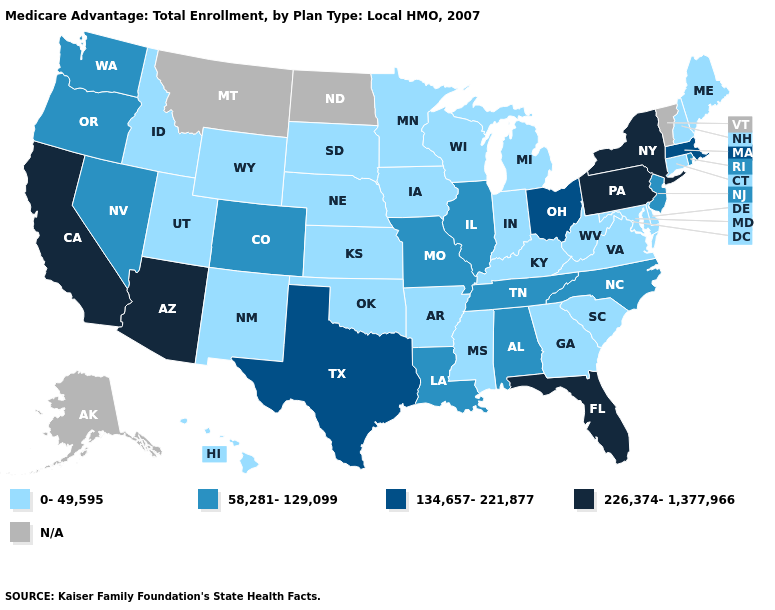Name the states that have a value in the range 0-49,595?
Answer briefly. Arkansas, Connecticut, Delaware, Georgia, Hawaii, Iowa, Idaho, Indiana, Kansas, Kentucky, Maryland, Maine, Michigan, Minnesota, Mississippi, Nebraska, New Hampshire, New Mexico, Oklahoma, South Carolina, South Dakota, Utah, Virginia, Wisconsin, West Virginia, Wyoming. Name the states that have a value in the range 134,657-221,877?
Short answer required. Massachusetts, Ohio, Texas. What is the lowest value in states that border Georgia?
Short answer required. 0-49,595. Name the states that have a value in the range 134,657-221,877?
Quick response, please. Massachusetts, Ohio, Texas. Does Ohio have the highest value in the MidWest?
Give a very brief answer. Yes. What is the value of Utah?
Answer briefly. 0-49,595. What is the value of Washington?
Keep it brief. 58,281-129,099. Which states have the lowest value in the MidWest?
Short answer required. Iowa, Indiana, Kansas, Michigan, Minnesota, Nebraska, South Dakota, Wisconsin. Name the states that have a value in the range 58,281-129,099?
Be succinct. Alabama, Colorado, Illinois, Louisiana, Missouri, North Carolina, New Jersey, Nevada, Oregon, Rhode Island, Tennessee, Washington. What is the value of California?
Quick response, please. 226,374-1,377,966. Name the states that have a value in the range N/A?
Answer briefly. Alaska, Montana, North Dakota, Vermont. Among the states that border Virginia , does North Carolina have the lowest value?
Keep it brief. No. 